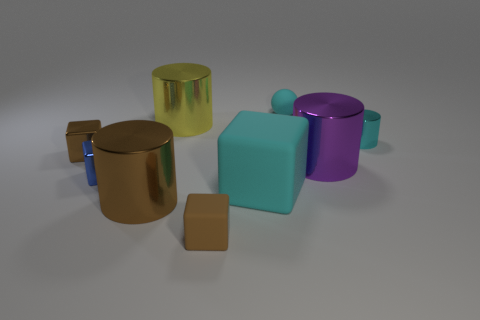The cyan block that is the same material as the small sphere is what size?
Your answer should be very brief. Large. There is a tiny metallic thing that is the same color as the matte ball; what is its shape?
Provide a short and direct response. Cylinder. What color is the block that is the same size as the purple metallic thing?
Your answer should be very brief. Cyan. Is the color of the small metallic object right of the big brown thing the same as the big matte cube?
Make the answer very short. Yes. How many cyan rubber cubes are in front of the tiny brown object that is in front of the brown metal cube?
Keep it short and to the point. 0. Is the material of the large purple cylinder the same as the small cyan cylinder?
Make the answer very short. Yes. What number of tiny cyan cylinders are to the left of the brown matte thing right of the large metallic object that is behind the cyan cylinder?
Your answer should be very brief. 0. The small matte object behind the small blue shiny cube is what color?
Make the answer very short. Cyan. The large thing that is behind the small object to the left of the tiny blue shiny object is what shape?
Offer a terse response. Cylinder. Is the large matte cube the same color as the sphere?
Provide a succinct answer. Yes. 